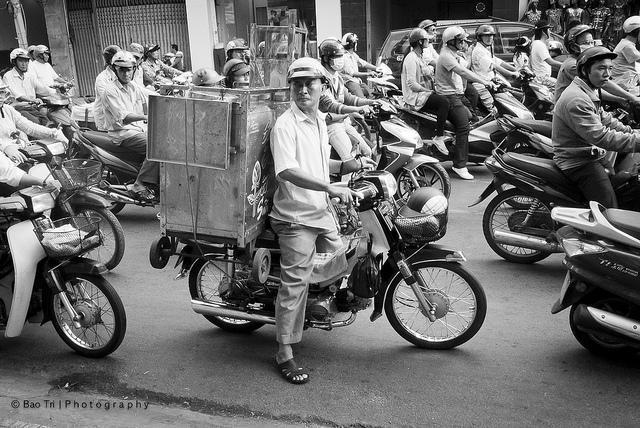How many motorcycles can you see?
Give a very brief answer. 8. How many people can be seen?
Give a very brief answer. 8. How many vases are taller than the others?
Give a very brief answer. 0. 